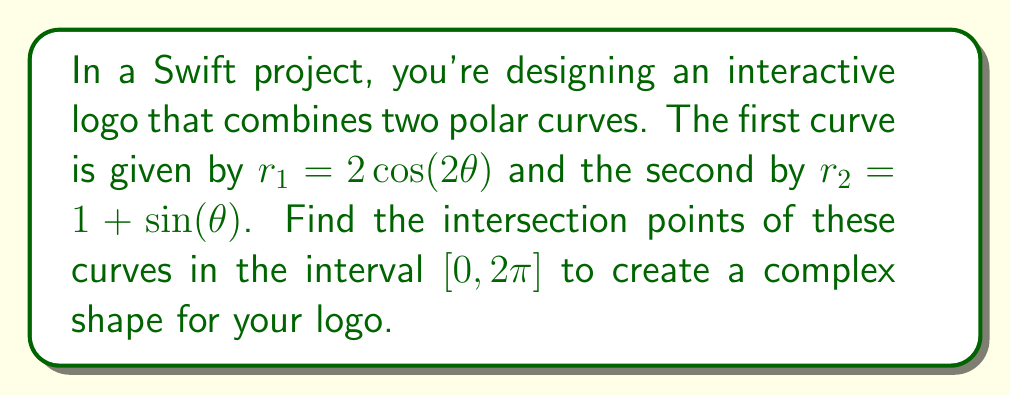Could you help me with this problem? To find the intersection points of these two polar curves, we need to solve the equation:

$$2\cos(2\theta) = 1 + \sin(\theta)$$

Let's approach this step-by-step:

1) First, recall the double angle formula for cosine:
   $\cos(2\theta) = 2\cos^2(\theta) - 1$

2) Substitute this into our original equation:
   $$2(2\cos^2(\theta) - 1) = 1 + \sin(\theta)$$

3) Simplify:
   $$4\cos^2(\theta) - 2 = 1 + \sin(\theta)$$
   $$4\cos^2(\theta) - 3 = \sin(\theta)$$

4) Square both sides:
   $$16\cos^4(\theta) - 24\cos^2(\theta) + 9 = \sin^2(\theta)$$

5) Recall the Pythagorean identity: $\sin^2(\theta) + \cos^2(\theta) = 1$
   Substitute $\sin^2(\theta) = 1 - \cos^2(\theta)$:
   
   $$16\cos^4(\theta) - 24\cos^2(\theta) + 9 = 1 - \cos^2(\theta)$$

6) Rearrange:
   $$16\cos^4(\theta) - 23\cos^2(\theta) + 8 = 0$$

7) Let $u = \cos^2(\theta)$. Then we have a quadratic in $u$:
   $$16u^2 - 23u + 8 = 0$$

8) Solve using the quadratic formula:
   $$u = \frac{23 \pm \sqrt{529 - 512}}{32} = \frac{23 \pm \sqrt{17}}{32}$$

9) Therefore:
   $$\cos^2(\theta) = \frac{23 + \sqrt{17}}{32} \approx 0.9619 \text{ or } \cos^2(\theta) = \frac{23 - \sqrt{17}}{32} \approx 0.4756$$

10) Taking the square root and considering the interval $[0, 2\pi]$, we get:
    $$\theta \approx 0.2748, 2.8668, 3.4164, 5.9784$$

11) Verify these solutions satisfy the original equation.

[asy]
import graph;
size(200);
real r1(real t) {return 2*cos(2*t);}
real r2(real t) {return 1+sin(t);}
path g1=polargraph(r1,0,2*pi,300);
path g2=polargraph(r2,0,2*pi,300);
draw(g1,blue);
draw(g2,red);
dot((r1(0.2748)*cos(0.2748),r1(0.2748)*sin(0.2748)));
dot((r1(2.8668)*cos(2.8668),r1(2.8668)*sin(2.8668)));
dot((r1(3.4164)*cos(3.4164),r1(3.4164)*sin(3.4164)));
dot((r1(5.9784)*cos(5.9784),r1(5.9784)*sin(5.9784)));
[/asy]
Answer: The intersection points occur at approximately $\theta = 0.2748, 2.8668, 3.4164, \text{ and } 5.9784$ radians. 